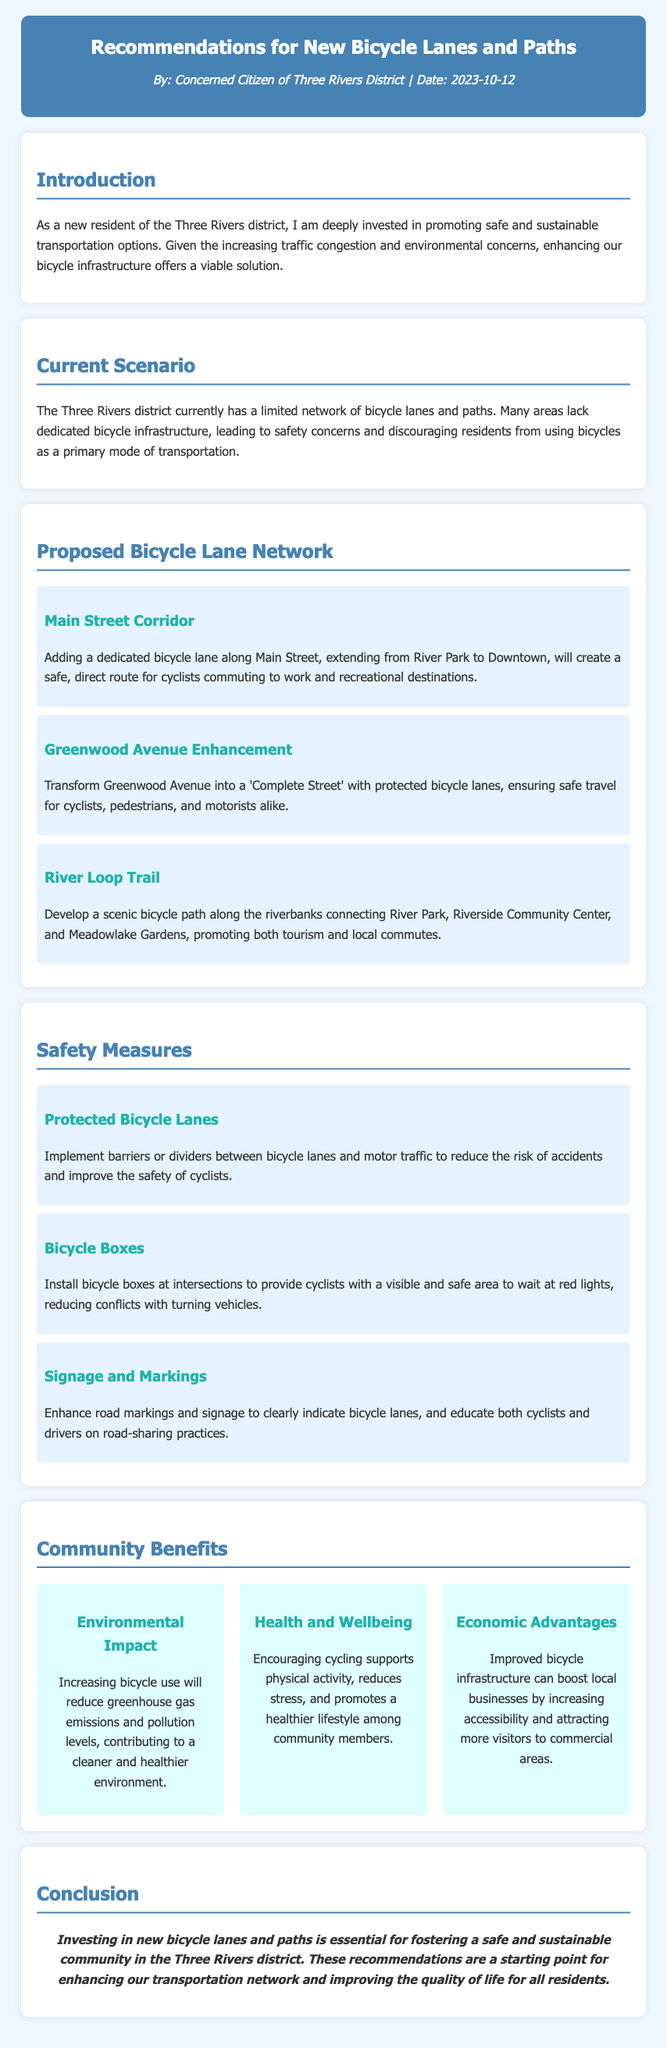what is the title of the document? The title of the document is in the header section, showcasing the focus of the content on bicycle infrastructure.
Answer: Recommendations for New Bicycle Lanes and Paths who authored the document? The author of the document is identified at the top, indicating their role in the community.
Answer: Concerned Citizen of Three Rivers District what date was the document created? The date is also specified in the author section, providing context for the recommendations.
Answer: 2023-10-12 which street is proposed for a dedicated bicycle lane? The proposal section details specific streets where bicycle lanes are suggested, such as Main Street.
Answer: Main Street Corridor what is one safety measure mentioned in the document? The safety measures section outlines different strategies to ensure cyclist safety, including specific initiatives.
Answer: Protected Bicycle Lanes how many benefits are described in the community benefits section? The benefits grid includes several distinct advantages of enhancing bicycle infrastructure, indicating the value of the proposal.
Answer: Three what is the focus of the proposed enhancement on Greenwood Avenue? The enhancement proposal provides a clear vision for how to develop the street to improve cycling safety and accessibility.
Answer: Complete Street what does the conclusion emphasize? The conclusion summarizes the overall message and necessity of the recommendations discussed in the document.
Answer: Safe and sustainable community 